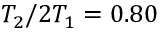<formula> <loc_0><loc_0><loc_500><loc_500>T _ { 2 } / 2 T _ { 1 } = 0 . 8 0</formula> 